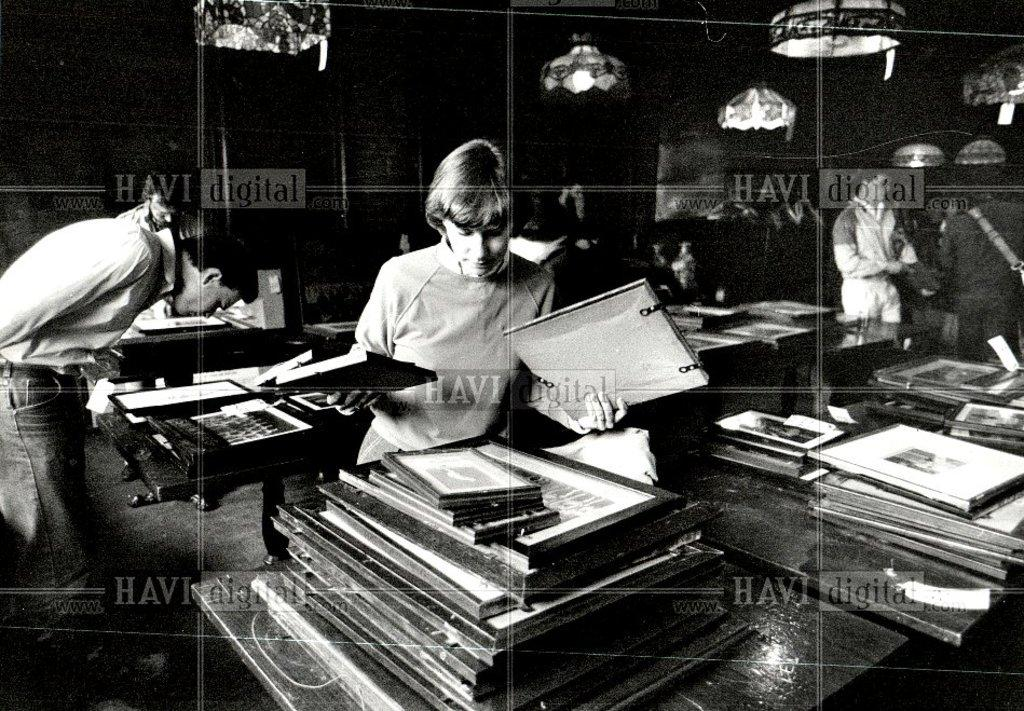What is the color scheme of the image? The image is black and white. Who or what can be seen in the image? There are people in the image. What type of furniture is present in the image? There are tables in the image. What objects are used to display or hold items in the image? There are frames in the image. What provides illumination in the image? There are lights in the image. How would you describe the overall lighting in the image? The background of the image is dark. Is there any rain visible in the image? No, there is no rain visible in the image. What type of steel objects can be seen in the image? There are no steel objects present in the image. 